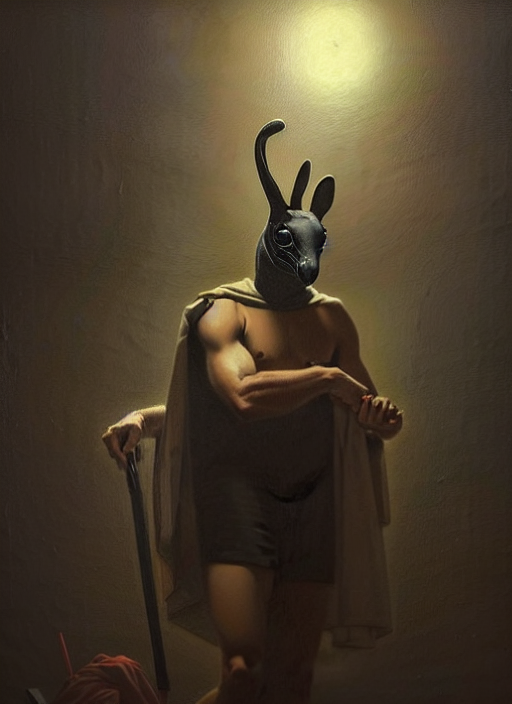How clear is this image?
A. Relatively clear
B. Extremely clear
C. Slightly clear
Answer with the option's letter from the given choices directly. The image is B. Extremely clear, with a crisp focus on the subject. The lighting is well-balanced, sharply defining the textures and colors. Fine details are easily discernible, contributing to the overall clarity of the visual composition. 